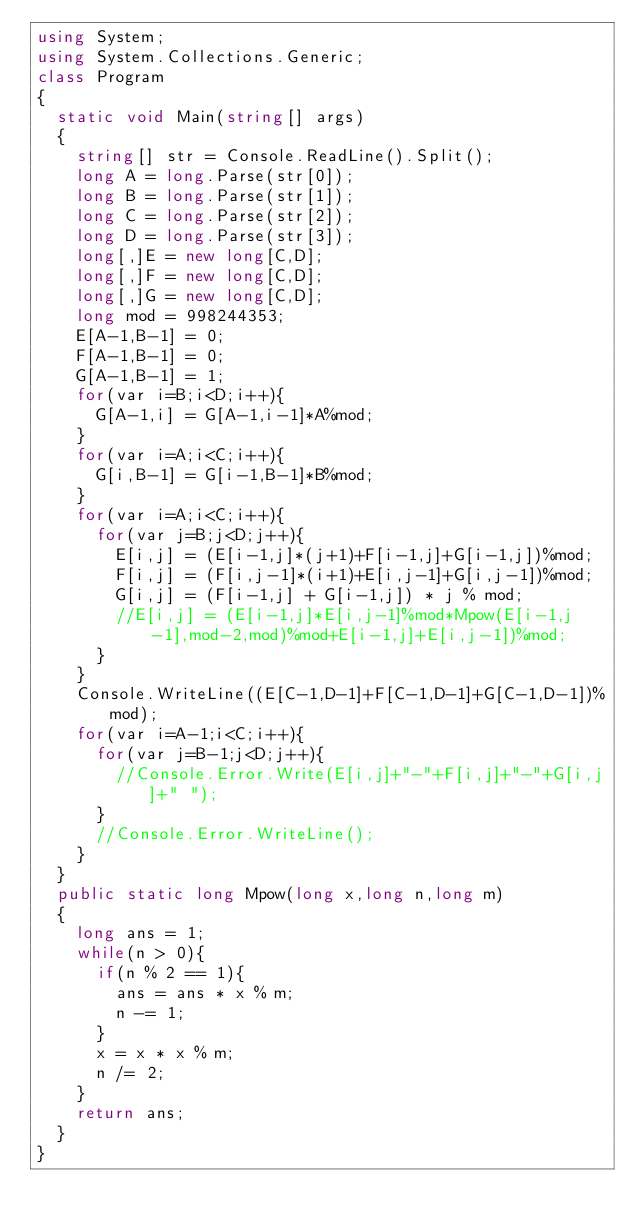<code> <loc_0><loc_0><loc_500><loc_500><_C#_>using System;
using System.Collections.Generic;
class Program
{
	static void Main(string[] args)
	{
		string[] str = Console.ReadLine().Split();
		long A = long.Parse(str[0]);
		long B = long.Parse(str[1]);
		long C = long.Parse(str[2]);
		long D = long.Parse(str[3]);
		long[,]E = new long[C,D];
		long[,]F = new long[C,D];
		long[,]G = new long[C,D];
		long mod = 998244353;
		E[A-1,B-1] = 0;
		F[A-1,B-1] = 0;
		G[A-1,B-1] = 1;
		for(var i=B;i<D;i++){
			G[A-1,i] = G[A-1,i-1]*A%mod;
		}
		for(var i=A;i<C;i++){
			G[i,B-1] = G[i-1,B-1]*B%mod;
		}
		for(var i=A;i<C;i++){
			for(var j=B;j<D;j++){
				E[i,j] = (E[i-1,j]*(j+1)+F[i-1,j]+G[i-1,j])%mod;
				F[i,j] = (F[i,j-1]*(i+1)+E[i,j-1]+G[i,j-1])%mod;
				G[i,j] = (F[i-1,j] + G[i-1,j]) * j % mod;
				//E[i,j] = (E[i-1,j]*E[i,j-1]%mod*Mpow(E[i-1,j-1],mod-2,mod)%mod+E[i-1,j]+E[i,j-1])%mod;
			}
		}
		Console.WriteLine((E[C-1,D-1]+F[C-1,D-1]+G[C-1,D-1])%mod);
		for(var i=A-1;i<C;i++){
			for(var j=B-1;j<D;j++){
				//Console.Error.Write(E[i,j]+"-"+F[i,j]+"-"+G[i,j]+" ");
			}
			//Console.Error.WriteLine();
		}
	}
	public static long Mpow(long x,long n,long m)
	{
		long ans = 1;
		while(n > 0){
			if(n % 2 == 1){
				ans = ans * x % m;
				n -= 1;
			}
			x = x * x % m;
			n /= 2;
		}
		return ans;
	}
}</code> 